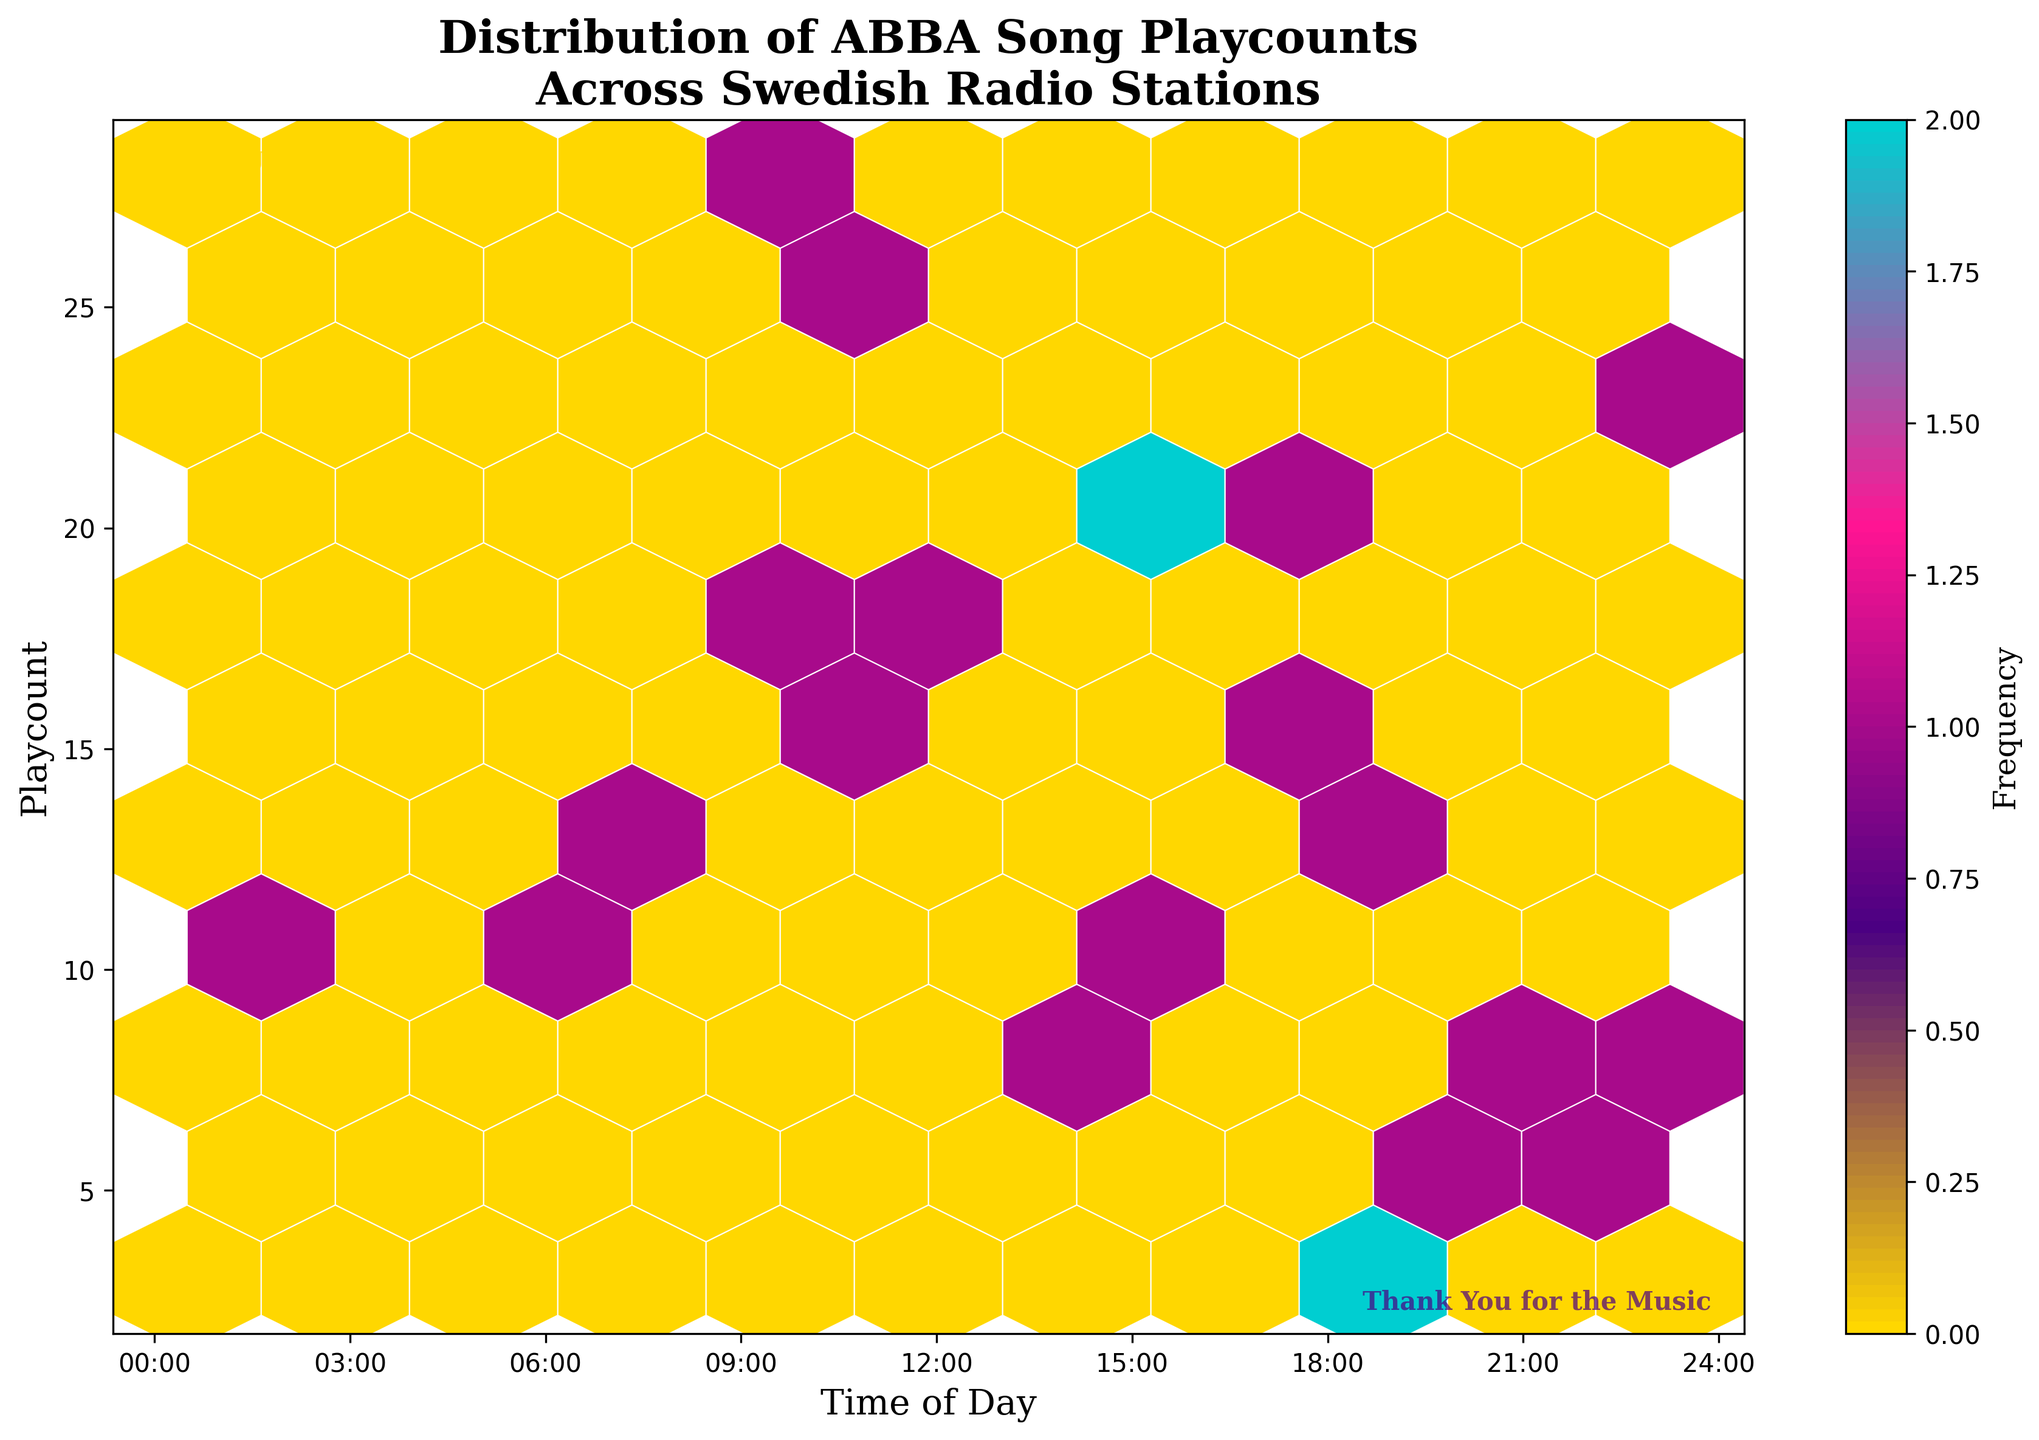What is the title of the plot? Look at the top of the figure to identify the title text. The title is typically displayed in a larger and bolder font than other text elements.
Answer: Distribution of ABBA Song Playcounts Across Swedish Radio Stations What is represented on the x-axis? The label for the x-axis is typically located below the horizontal axis of the plot. Reading this label will reveal what is represented by the x-axis.
Answer: Time of Day At what time of day is the playcount highest? Examine the hexagons' concentration and color for the highest density. The x-axis will help identify the specific time of day. The darker the hexagon, the higher the frequency.
Answer: 10:00 Which radio station had a playcount in the late evening (22:00)? Locate the hexagons around 22:00 on the x-axis and identify the corresponding station from the playcount.
Answer: NRJ Sweden How many bands of color are used in the colormap? Counting the different shades transitioning from one color to another along the color bar on the right side of the plot will reveal this.
Answer: Four What time range shows the least playcount activity? Identify the sections on the plot with the fewest and lightest hexagons. The x-axis will help determine the time range.
Answer: 18:00 to 20:00 What is the maximum playcount recorded, and at what time does it occur? Locate the highest point on the y-axis and trace it back to its corresponding hexagon. Use the x-axis to determine the time.
Answer: 28 at 09:45 Which two times of day show the highest and lowest playcounts? Determine the densest and sparsest clusters of hexagons on the plot, referencing the x-axis for accurate times.
Answer: Highest at 09:45, lowest at 18:30 What does the colorbar indicate, and how is it used in the plot? Check the label next to the colorbar to identify what it represents, and observe how the colors correspond to the density of hexagons in the plot.
Answer: Indicates Frequency Are there any patterns or clusters in the distribution of playcounts throughout the day? Look for visually identifiable patterns, such as clusters or trends, in the hexbins across different times of the day. This analysis involves scanning the plot horizontally.
Answer: Yes, higher playcounts around mid-morning and lower playcounts in the early evening 